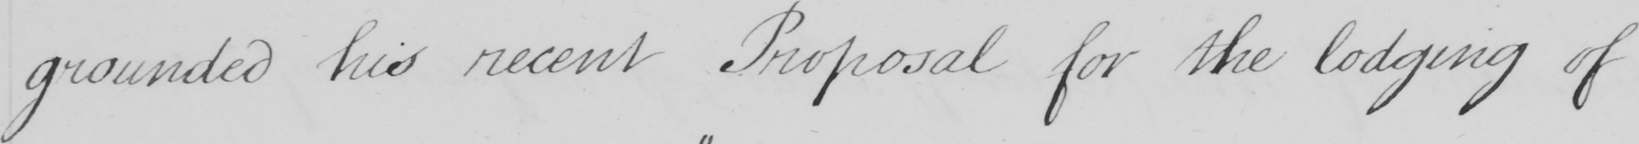What text is written in this handwritten line? grounded his recent Proposal for the lodging of 